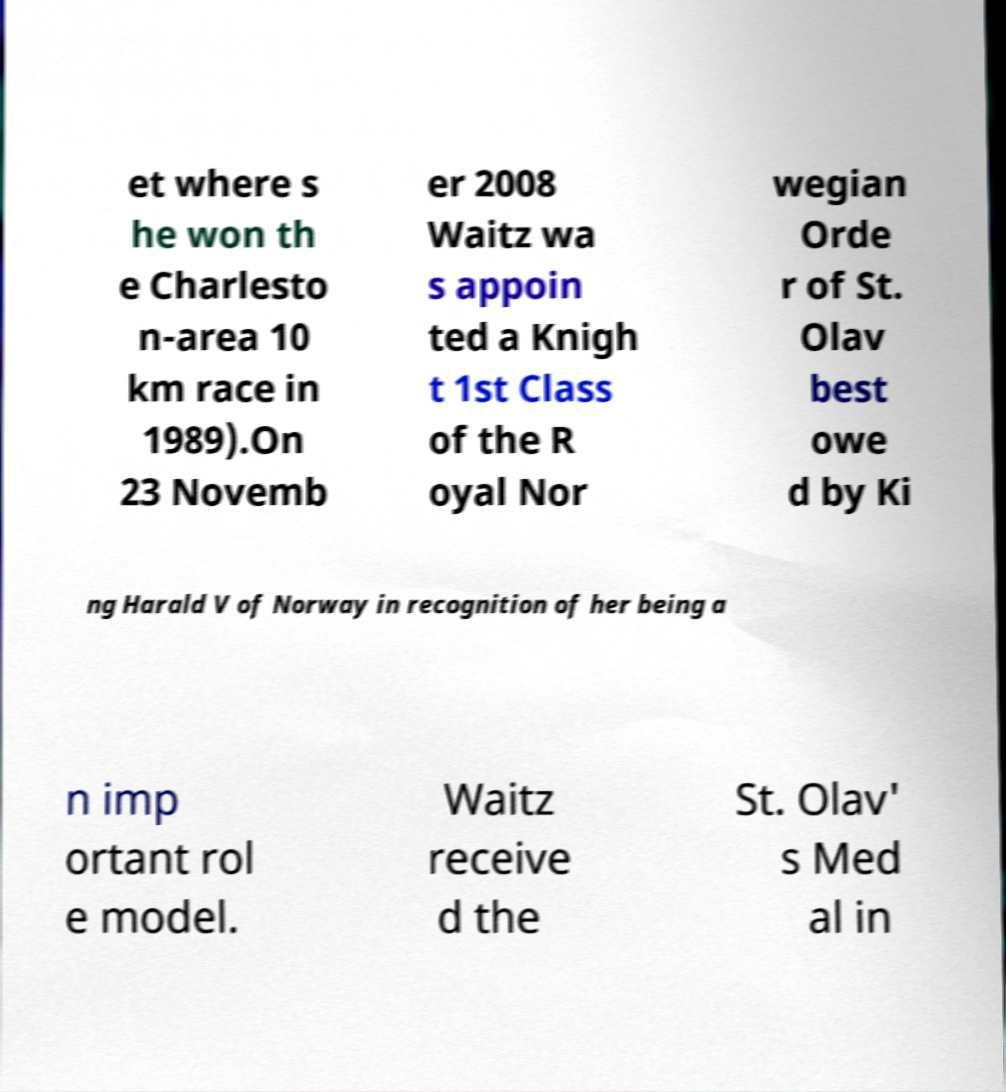What messages or text are displayed in this image? I need them in a readable, typed format. et where s he won th e Charlesto n-area 10 km race in 1989).On 23 Novemb er 2008 Waitz wa s appoin ted a Knigh t 1st Class of the R oyal Nor wegian Orde r of St. Olav best owe d by Ki ng Harald V of Norway in recognition of her being a n imp ortant rol e model. Waitz receive d the St. Olav' s Med al in 